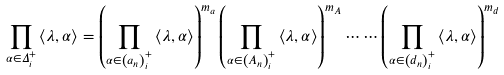<formula> <loc_0><loc_0><loc_500><loc_500>\prod _ { \alpha \in \Delta _ { i } ^ { + } } \left \langle \lambda , \alpha \right \rangle = \left ( \prod _ { \alpha \in \left ( a _ { n } \right ) _ { i } ^ { + } } \left \langle \lambda , \alpha \right \rangle \right ) ^ { m _ { a } } \left ( \prod _ { \alpha \in \left ( A _ { n } \right ) _ { i } ^ { + } } \left \langle \lambda , \alpha \right \rangle \right ) ^ { m _ { A } } \cdots \cdots \left ( \prod _ { \alpha \in \left ( d _ { n } \right ) _ { i } ^ { + } } \left \langle \lambda , \alpha \right \rangle \right ) ^ { m _ { d } }</formula> 